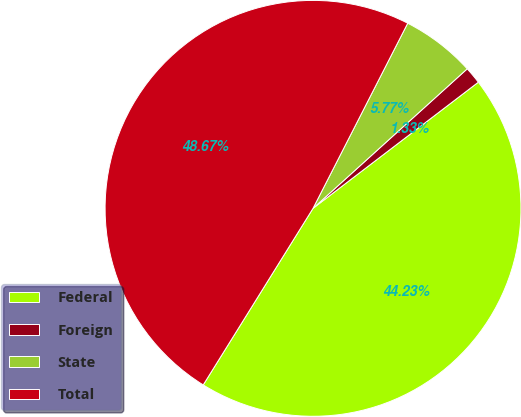Convert chart to OTSL. <chart><loc_0><loc_0><loc_500><loc_500><pie_chart><fcel>Federal<fcel>Foreign<fcel>State<fcel>Total<nl><fcel>44.23%<fcel>1.33%<fcel>5.77%<fcel>48.67%<nl></chart> 